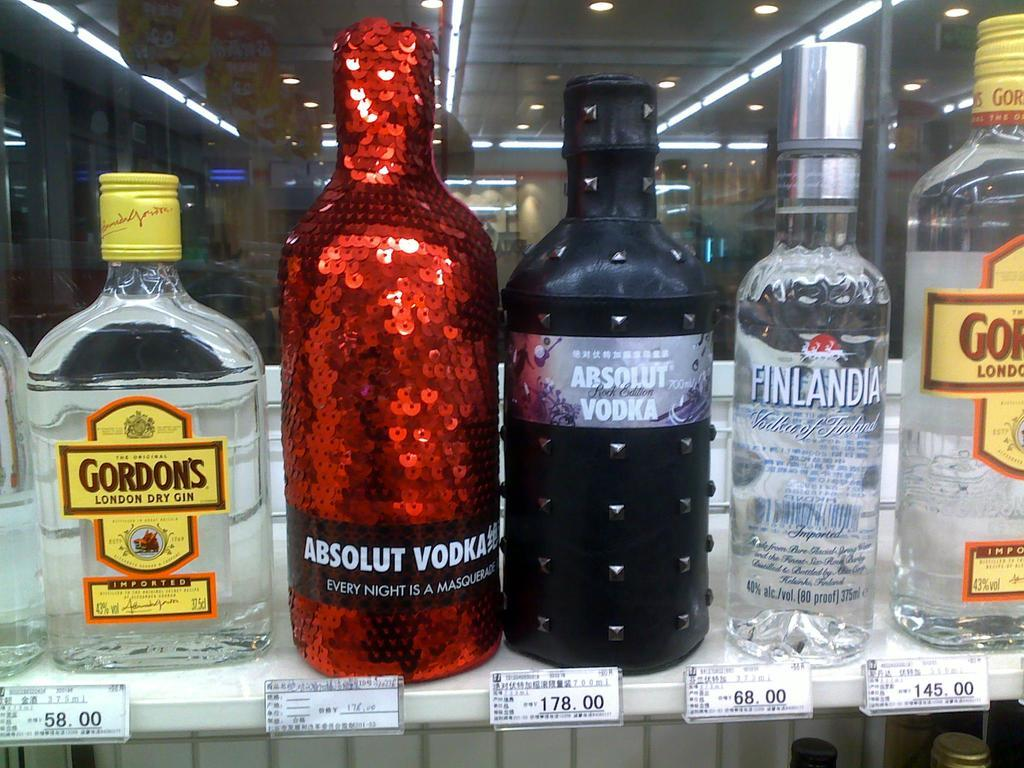<image>
Write a terse but informative summary of the picture. A bottle of Gordon's dry gin sits next to a sequined bottle of vodka. 